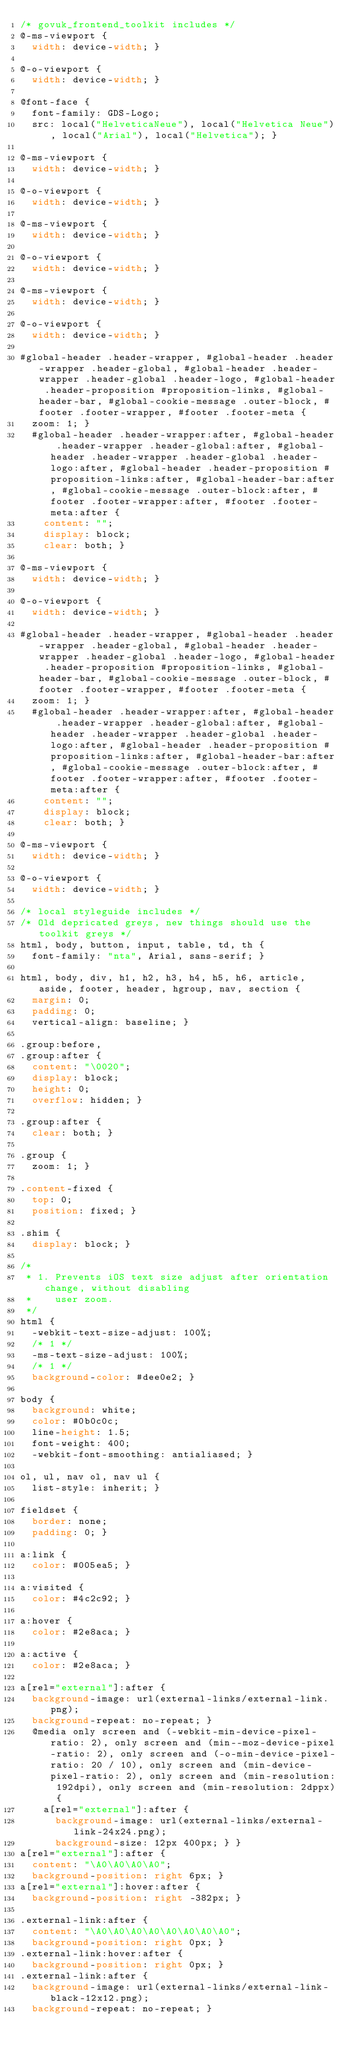Convert code to text. <code><loc_0><loc_0><loc_500><loc_500><_CSS_>/* govuk_frontend_toolkit includes */
@-ms-viewport {
  width: device-width; }

@-o-viewport {
  width: device-width; }

@font-face {
  font-family: GDS-Logo;
  src: local("HelveticaNeue"), local("Helvetica Neue"), local("Arial"), local("Helvetica"); }

@-ms-viewport {
  width: device-width; }

@-o-viewport {
  width: device-width; }

@-ms-viewport {
  width: device-width; }

@-o-viewport {
  width: device-width; }

@-ms-viewport {
  width: device-width; }

@-o-viewport {
  width: device-width; }

#global-header .header-wrapper, #global-header .header-wrapper .header-global, #global-header .header-wrapper .header-global .header-logo, #global-header .header-proposition #proposition-links, #global-header-bar, #global-cookie-message .outer-block, #footer .footer-wrapper, #footer .footer-meta {
  zoom: 1; }
  #global-header .header-wrapper:after, #global-header .header-wrapper .header-global:after, #global-header .header-wrapper .header-global .header-logo:after, #global-header .header-proposition #proposition-links:after, #global-header-bar:after, #global-cookie-message .outer-block:after, #footer .footer-wrapper:after, #footer .footer-meta:after {
    content: "";
    display: block;
    clear: both; }

@-ms-viewport {
  width: device-width; }

@-o-viewport {
  width: device-width; }

#global-header .header-wrapper, #global-header .header-wrapper .header-global, #global-header .header-wrapper .header-global .header-logo, #global-header .header-proposition #proposition-links, #global-header-bar, #global-cookie-message .outer-block, #footer .footer-wrapper, #footer .footer-meta {
  zoom: 1; }
  #global-header .header-wrapper:after, #global-header .header-wrapper .header-global:after, #global-header .header-wrapper .header-global .header-logo:after, #global-header .header-proposition #proposition-links:after, #global-header-bar:after, #global-cookie-message .outer-block:after, #footer .footer-wrapper:after, #footer .footer-meta:after {
    content: "";
    display: block;
    clear: both; }

@-ms-viewport {
  width: device-width; }

@-o-viewport {
  width: device-width; }

/* local styleguide includes */
/* Old depricated greys, new things should use the toolkit greys */
html, body, button, input, table, td, th {
  font-family: "nta", Arial, sans-serif; }

html, body, div, h1, h2, h3, h4, h5, h6, article, aside, footer, header, hgroup, nav, section {
  margin: 0;
  padding: 0;
  vertical-align: baseline; }

.group:before,
.group:after {
  content: "\0020";
  display: block;
  height: 0;
  overflow: hidden; }

.group:after {
  clear: both; }

.group {
  zoom: 1; }

.content-fixed {
  top: 0;
  position: fixed; }

.shim {
  display: block; }

/*
 * 1. Prevents iOS text size adjust after orientation change, without disabling
 *    user zoom.
 */
html {
  -webkit-text-size-adjust: 100%;
  /* 1 */
  -ms-text-size-adjust: 100%;
  /* 1 */
  background-color: #dee0e2; }

body {
  background: white;
  color: #0b0c0c;
  line-height: 1.5;
  font-weight: 400;
  -webkit-font-smoothing: antialiased; }

ol, ul, nav ol, nav ul {
  list-style: inherit; }

fieldset {
  border: none;
  padding: 0; }

a:link {
  color: #005ea5; }

a:visited {
  color: #4c2c92; }

a:hover {
  color: #2e8aca; }

a:active {
  color: #2e8aca; }

a[rel="external"]:after {
  background-image: url(external-links/external-link.png);
  background-repeat: no-repeat; }
  @media only screen and (-webkit-min-device-pixel-ratio: 2), only screen and (min--moz-device-pixel-ratio: 2), only screen and (-o-min-device-pixel-ratio: 20 / 10), only screen and (min-device-pixel-ratio: 2), only screen and (min-resolution: 192dpi), only screen and (min-resolution: 2dppx) {
    a[rel="external"]:after {
      background-image: url(external-links/external-link-24x24.png);
      background-size: 12px 400px; } }
a[rel="external"]:after {
  content: "\A0\A0\A0\A0";
  background-position: right 6px; }
a[rel="external"]:hover:after {
  background-position: right -382px; }

.external-link:after {
  content: "\A0\A0\A0\A0\A0\A0\A0\A0";
  background-position: right 0px; }
.external-link:hover:after {
  background-position: right 0px; }
.external-link:after {
  background-image: url(external-links/external-link-black-12x12.png);
  background-repeat: no-repeat; }</code> 